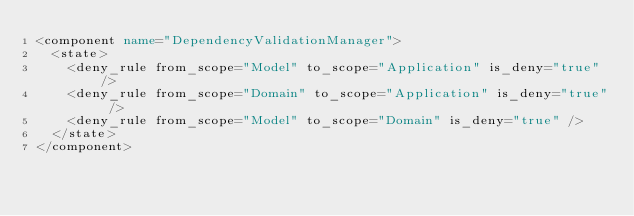Convert code to text. <code><loc_0><loc_0><loc_500><loc_500><_XML_><component name="DependencyValidationManager">
  <state>
    <deny_rule from_scope="Model" to_scope="Application" is_deny="true" />
    <deny_rule from_scope="Domain" to_scope="Application" is_deny="true" />
    <deny_rule from_scope="Model" to_scope="Domain" is_deny="true" />
  </state>
</component></code> 